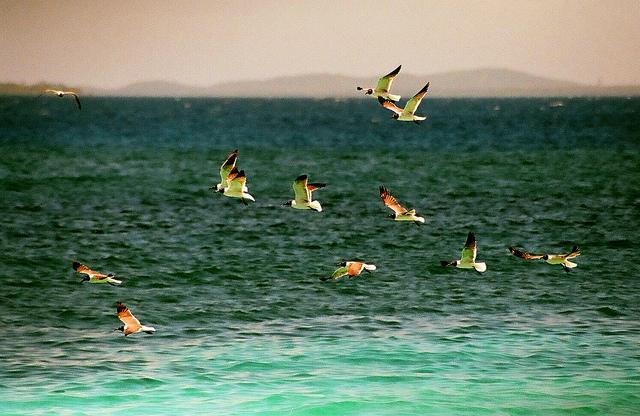What makes this picture look tropical?
Give a very brief answer. Water. Are the birds looking to feed?
Give a very brief answer. Yes. How many birds are shown?
Give a very brief answer. 11. 